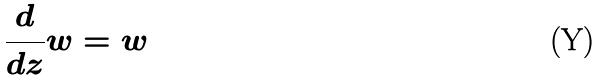<formula> <loc_0><loc_0><loc_500><loc_500>\frac { d } { d z } w = w</formula> 